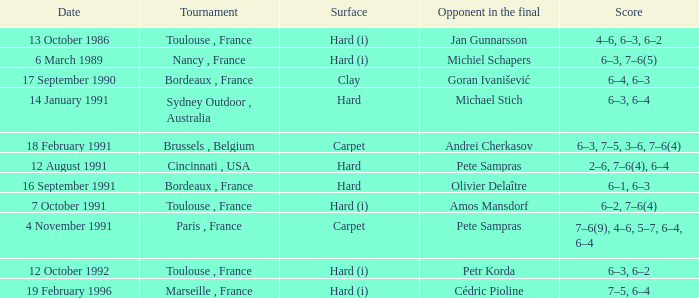What is the score of the contest with olivier delaître as the rival in the final? 6–1, 6–3. Could you parse the entire table as a dict? {'header': ['Date', 'Tournament', 'Surface', 'Opponent in the final', 'Score'], 'rows': [['13 October 1986', 'Toulouse , France', 'Hard (i)', 'Jan Gunnarsson', '4–6, 6–3, 6–2'], ['6 March 1989', 'Nancy , France', 'Hard (i)', 'Michiel Schapers', '6–3, 7–6(5)'], ['17 September 1990', 'Bordeaux , France', 'Clay', 'Goran Ivanišević', '6–4, 6–3'], ['14 January 1991', 'Sydney Outdoor , Australia', 'Hard', 'Michael Stich', '6–3, 6–4'], ['18 February 1991', 'Brussels , Belgium', 'Carpet', 'Andrei Cherkasov', '6–3, 7–5, 3–6, 7–6(4)'], ['12 August 1991', 'Cincinnati , USA', 'Hard', 'Pete Sampras', '2–6, 7–6(4), 6–4'], ['16 September 1991', 'Bordeaux , France', 'Hard', 'Olivier Delaître', '6–1, 6–3'], ['7 October 1991', 'Toulouse , France', 'Hard (i)', 'Amos Mansdorf', '6–2, 7–6(4)'], ['4 November 1991', 'Paris , France', 'Carpet', 'Pete Sampras', '7–6(9), 4–6, 5–7, 6–4, 6–4'], ['12 October 1992', 'Toulouse , France', 'Hard (i)', 'Petr Korda', '6–3, 6–2'], ['19 February 1996', 'Marseille , France', 'Hard (i)', 'Cédric Pioline', '7–5, 6–4']]} 